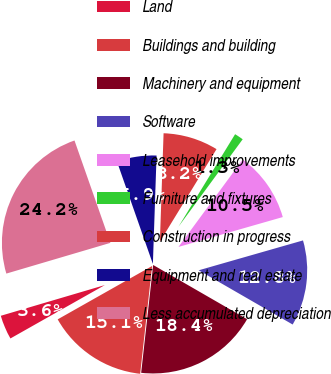Convert chart to OTSL. <chart><loc_0><loc_0><loc_500><loc_500><pie_chart><fcel>Land<fcel>Buildings and building<fcel>Machinery and equipment<fcel>Software<fcel>Leasehold improvements<fcel>Furniture and fixtures<fcel>Construction in progress<fcel>Equipment and real estate<fcel>Less accumulated depreciation<nl><fcel>3.62%<fcel>15.05%<fcel>18.43%<fcel>12.77%<fcel>10.48%<fcel>1.34%<fcel>8.2%<fcel>5.91%<fcel>24.2%<nl></chart> 